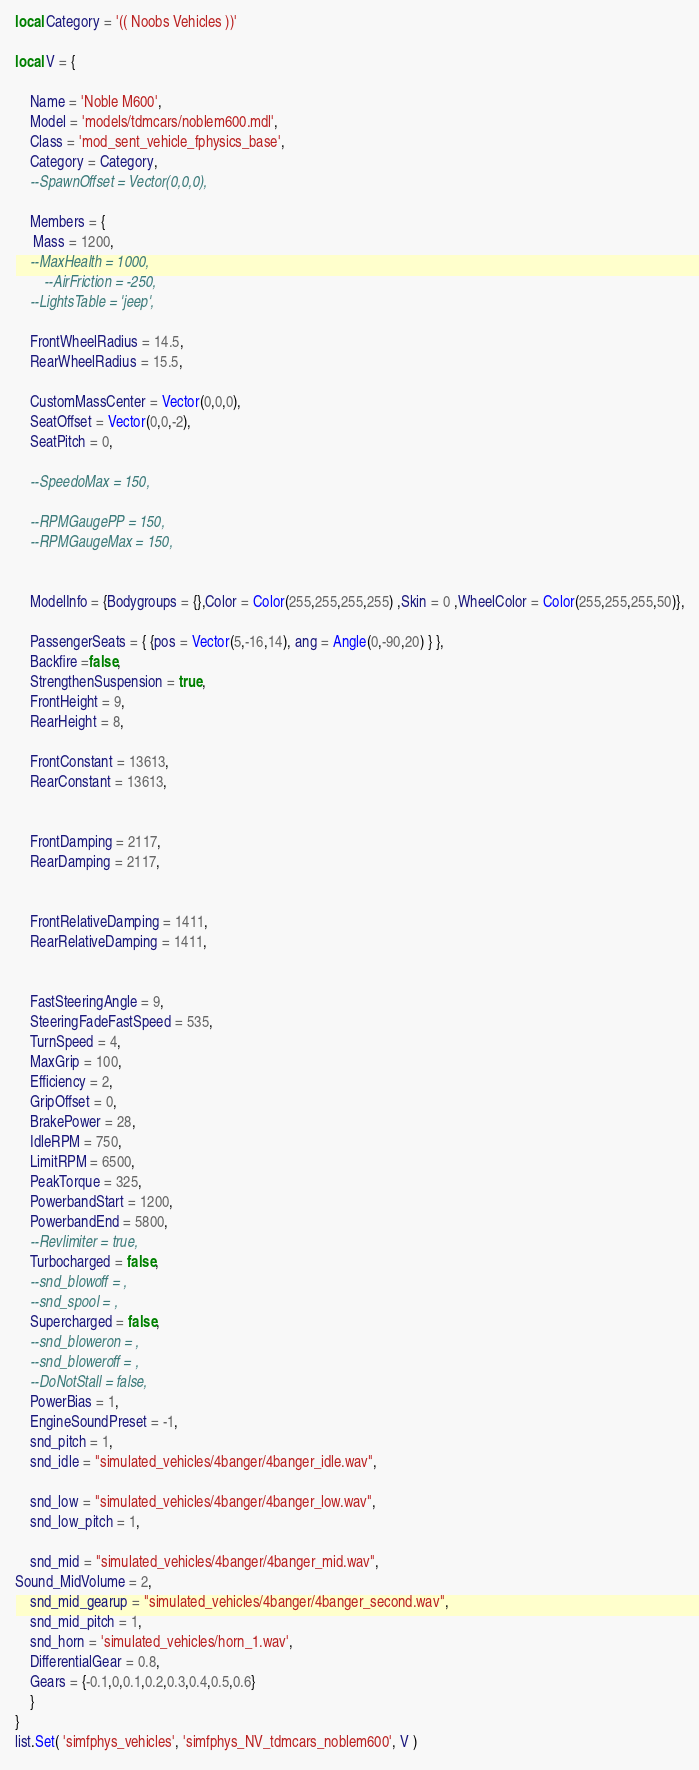<code> <loc_0><loc_0><loc_500><loc_500><_Lua_>local Category = '(( Noobs Vehicles ))'

local V = { 

    Name = 'Noble M600',
    Model = 'models/tdmcars/noblem600.mdl',
    Class = 'mod_sent_vehicle_fphysics_base',
    Category = Category,
    --SpawnOffset = Vector(0,0,0),

    Members = {
     Mass = 1200,
    --MaxHealth = 1000,
    	--AirFriction = -250,
    --LightsTable = 'jeep', 

    FrontWheelRadius = 14.5,
    RearWheelRadius = 15.5,

    CustomMassCenter = Vector(0,0,0),
    SeatOffset = Vector(0,0,-2),
    SeatPitch = 0,

    --SpeedoMax = 150,

    --RPMGaugePP = 150,
    --RPMGaugeMax = 150,

    
    ModelInfo = {Bodygroups = {},Color = Color(255,255,255,255) ,Skin = 0 ,WheelColor = Color(255,255,255,50)},

    PassengerSeats = { {pos = Vector(5,-16,14), ang = Angle(0,-90,20) } },
    Backfire =false,
    StrengthenSuspension = true,
    FrontHeight = 9,
    RearHeight = 8,

    FrontConstant = 13613,
    RearConstant = 13613,


    FrontDamping = 2117,
    RearDamping = 2117,


    FrontRelativeDamping = 1411, 
    RearRelativeDamping = 1411,


    FastSteeringAngle = 9,
    SteeringFadeFastSpeed = 535,
    TurnSpeed = 4,
    MaxGrip = 100,
    Efficiency = 2,
    GripOffset = 0,
    BrakePower = 28,
    IdleRPM = 750,
    LimitRPM = 6500,
    PeakTorque = 325,
    PowerbandStart = 1200, 
    PowerbandEnd = 5800,
    --Revlimiter = true,
    Turbocharged = false,
    --snd_blowoff = , 
    --snd_spool = ,
    Supercharged = false,
    --snd_bloweron = ,
    --snd_bloweroff = ,
    --DoNotStall = false, 
    PowerBias = 1,	
    EngineSoundPreset = -1,
    snd_pitch = 1,
    snd_idle = "simulated_vehicles/4banger/4banger_idle.wav",

    snd_low = "simulated_vehicles/4banger/4banger_low.wav",
    snd_low_pitch = 1,

    snd_mid = "simulated_vehicles/4banger/4banger_mid.wav",
Sound_MidVolume = 2,
    snd_mid_gearup = "simulated_vehicles/4banger/4banger_second.wav",
    snd_mid_pitch = 1,
    snd_horn = 'simulated_vehicles/horn_1.wav', 
    DifferentialGear = 0.8,
    Gears = {-0.1,0,0.1,0.2,0.3,0.4,0.5,0.6}
    }
}
list.Set( 'simfphys_vehicles', 'simfphys_NV_tdmcars_noblem600', V ) </code> 